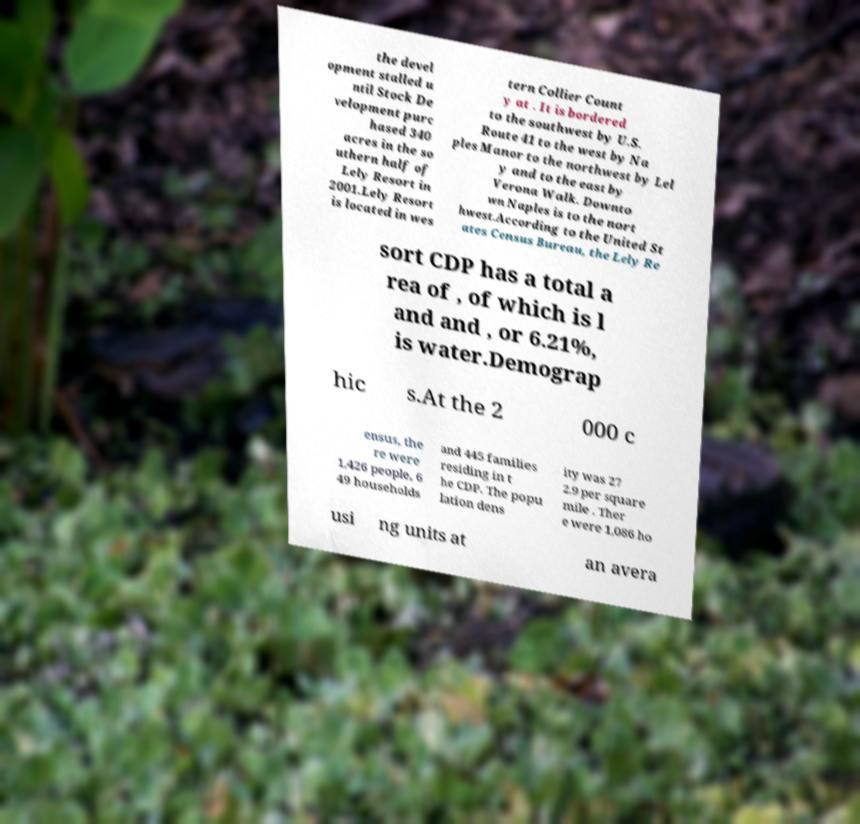Could you assist in decoding the text presented in this image and type it out clearly? the devel opment stalled u ntil Stock De velopment purc hased 340 acres in the so uthern half of Lely Resort in 2001.Lely Resort is located in wes tern Collier Count y at . It is bordered to the southwest by U.S. Route 41 to the west by Na ples Manor to the northwest by Lel y and to the east by Verona Walk. Downto wn Naples is to the nort hwest.According to the United St ates Census Bureau, the Lely Re sort CDP has a total a rea of , of which is l and and , or 6.21%, is water.Demograp hic s.At the 2 000 c ensus, the re were 1,426 people, 6 49 households and 445 families residing in t he CDP. The popu lation dens ity was 27 2.9 per square mile . Ther e were 1,086 ho usi ng units at an avera 